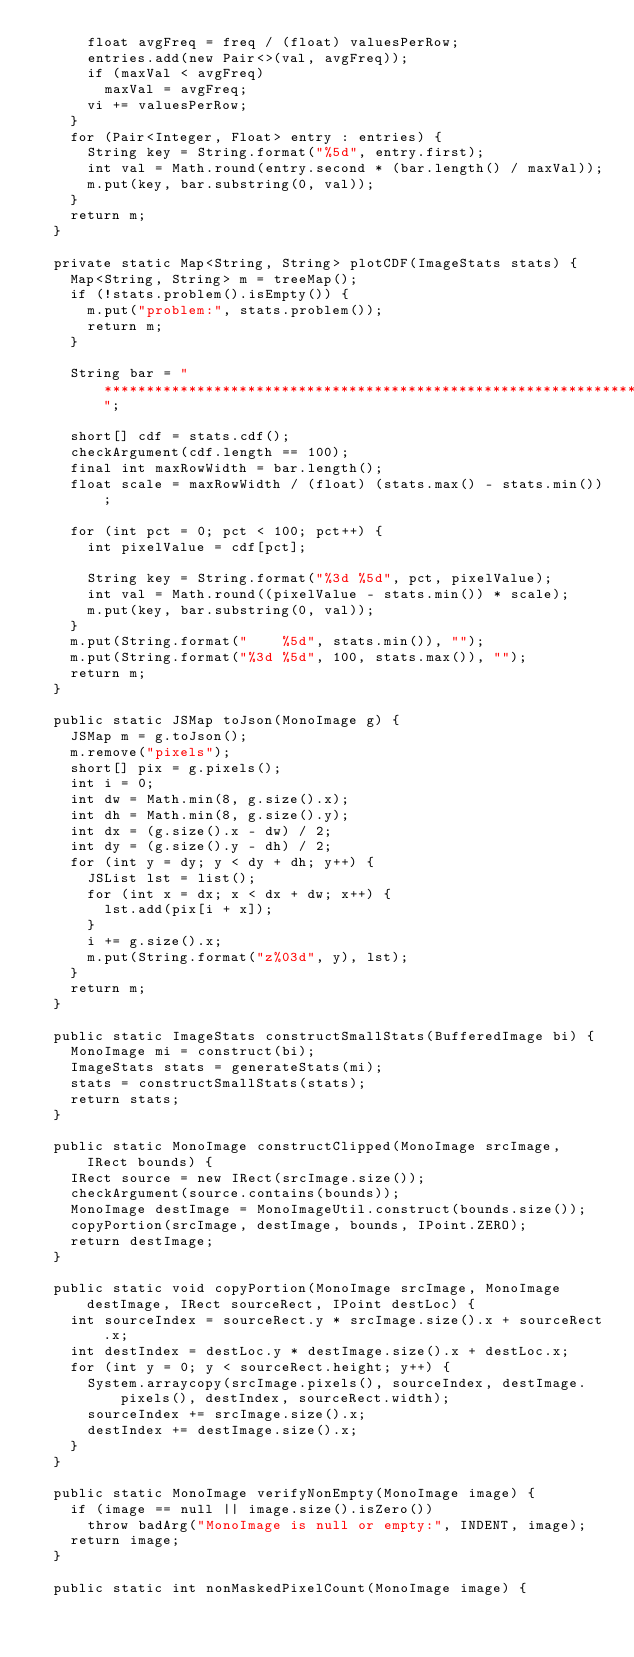Convert code to text. <code><loc_0><loc_0><loc_500><loc_500><_Java_>      float avgFreq = freq / (float) valuesPerRow;
      entries.add(new Pair<>(val, avgFreq));
      if (maxVal < avgFreq)
        maxVal = avgFreq;
      vi += valuesPerRow;
    }
    for (Pair<Integer, Float> entry : entries) {
      String key = String.format("%5d", entry.first);
      int val = Math.round(entry.second * (bar.length() / maxVal));
      m.put(key, bar.substring(0, val));
    }
    return m;
  }

  private static Map<String, String> plotCDF(ImageStats stats) {
    Map<String, String> m = treeMap();
    if (!stats.problem().isEmpty()) {
      m.put("problem:", stats.problem());
      return m;
    }

    String bar = "**********************************************************************";

    short[] cdf = stats.cdf();
    checkArgument(cdf.length == 100);
    final int maxRowWidth = bar.length();
    float scale = maxRowWidth / (float) (stats.max() - stats.min());

    for (int pct = 0; pct < 100; pct++) {
      int pixelValue = cdf[pct];

      String key = String.format("%3d %5d", pct, pixelValue);
      int val = Math.round((pixelValue - stats.min()) * scale);
      m.put(key, bar.substring(0, val));
    }
    m.put(String.format("    %5d", stats.min()), "");
    m.put(String.format("%3d %5d", 100, stats.max()), "");
    return m;
  }

  public static JSMap toJson(MonoImage g) {
    JSMap m = g.toJson();
    m.remove("pixels");
    short[] pix = g.pixels();
    int i = 0;
    int dw = Math.min(8, g.size().x);
    int dh = Math.min(8, g.size().y);
    int dx = (g.size().x - dw) / 2;
    int dy = (g.size().y - dh) / 2;
    for (int y = dy; y < dy + dh; y++) {
      JSList lst = list();
      for (int x = dx; x < dx + dw; x++) {
        lst.add(pix[i + x]);
      }
      i += g.size().x;
      m.put(String.format("z%03d", y), lst);
    }
    return m;
  }

  public static ImageStats constructSmallStats(BufferedImage bi) {
    MonoImage mi = construct(bi);
    ImageStats stats = generateStats(mi);
    stats = constructSmallStats(stats);
    return stats;
  }

  public static MonoImage constructClipped(MonoImage srcImage, IRect bounds) {
    IRect source = new IRect(srcImage.size());
    checkArgument(source.contains(bounds));
    MonoImage destImage = MonoImageUtil.construct(bounds.size());
    copyPortion(srcImage, destImage, bounds, IPoint.ZERO);
    return destImage;
  }

  public static void copyPortion(MonoImage srcImage, MonoImage destImage, IRect sourceRect, IPoint destLoc) {
    int sourceIndex = sourceRect.y * srcImage.size().x + sourceRect.x;
    int destIndex = destLoc.y * destImage.size().x + destLoc.x;
    for (int y = 0; y < sourceRect.height; y++) {
      System.arraycopy(srcImage.pixels(), sourceIndex, destImage.pixels(), destIndex, sourceRect.width);
      sourceIndex += srcImage.size().x;
      destIndex += destImage.size().x;
    }
  }

  public static MonoImage verifyNonEmpty(MonoImage image) {
    if (image == null || image.size().isZero())
      throw badArg("MonoImage is null or empty:", INDENT, image);
    return image;
  }

  public static int nonMaskedPixelCount(MonoImage image) {</code> 